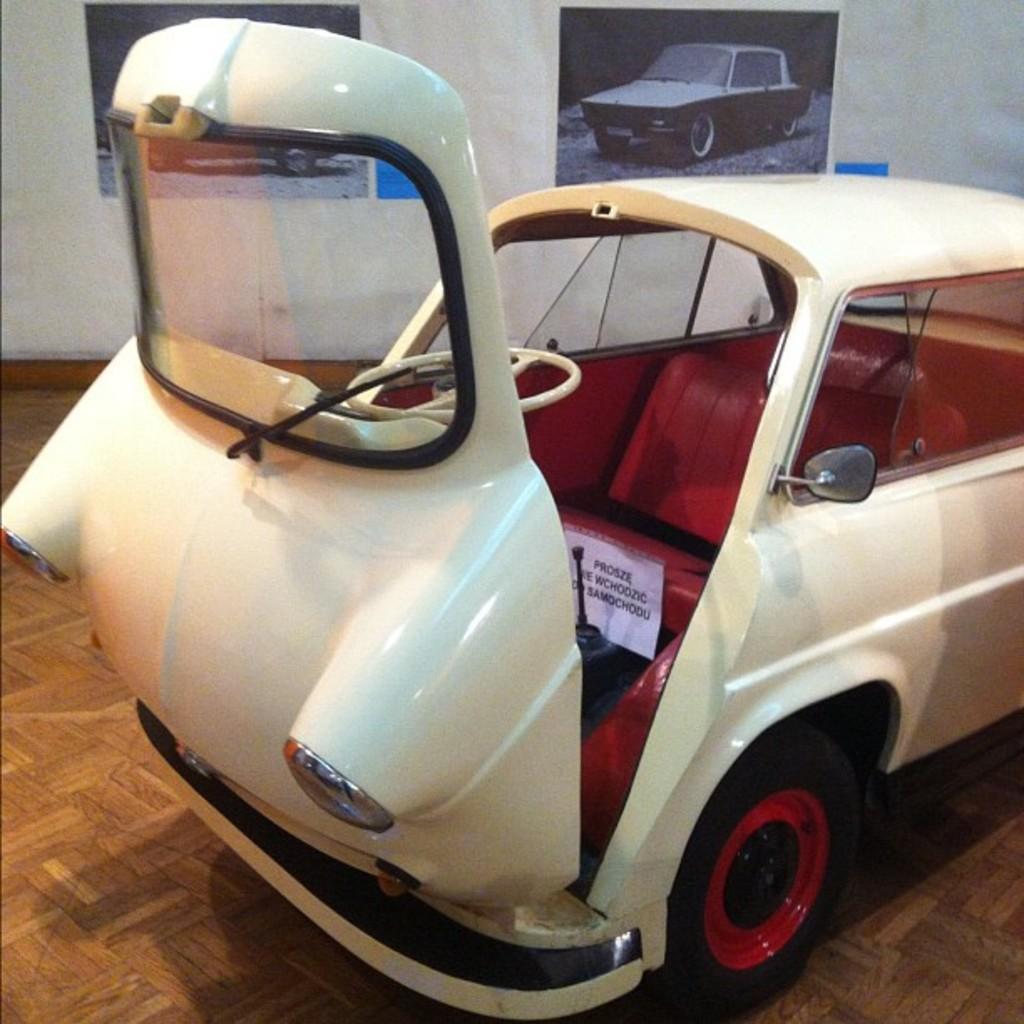How would you summarize this image in a sentence or two? In this image we can see a white car, there are posters with some texts, and images on it, also we can see a wall. 